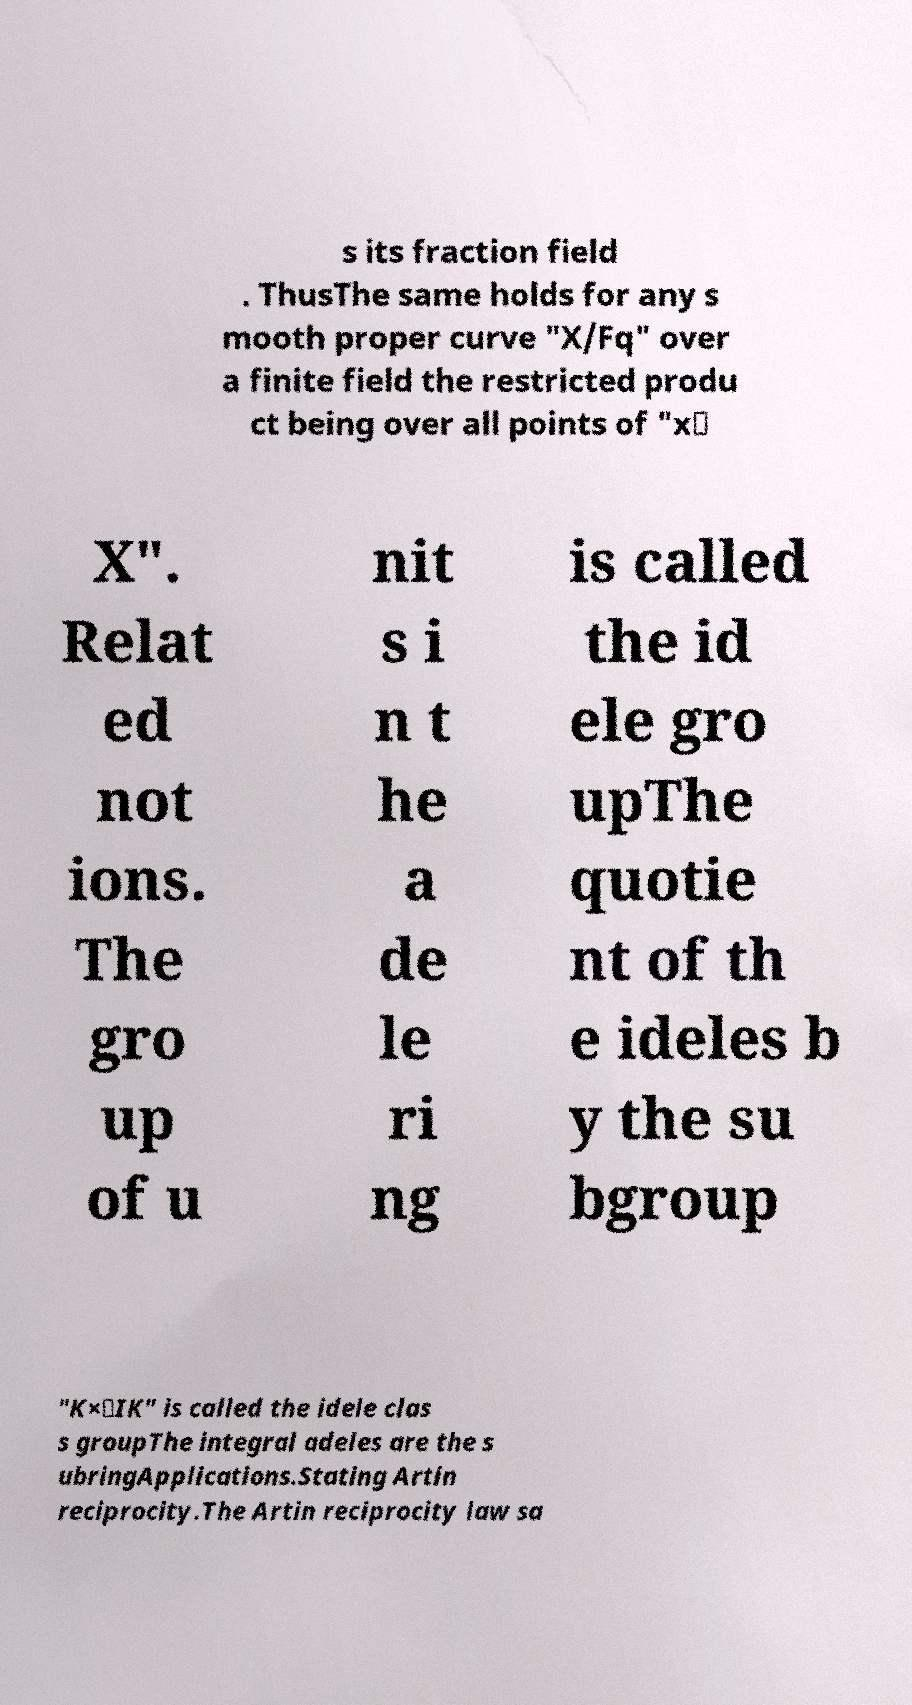Could you extract and type out the text from this image? s its fraction field . ThusThe same holds for any s mooth proper curve "X/Fq" over a finite field the restricted produ ct being over all points of "x∈ X". Relat ed not ions. The gro up of u nit s i n t he a de le ri ng is called the id ele gro upThe quotie nt of th e ideles b y the su bgroup "K×⊆IK" is called the idele clas s groupThe integral adeles are the s ubringApplications.Stating Artin reciprocity.The Artin reciprocity law sa 